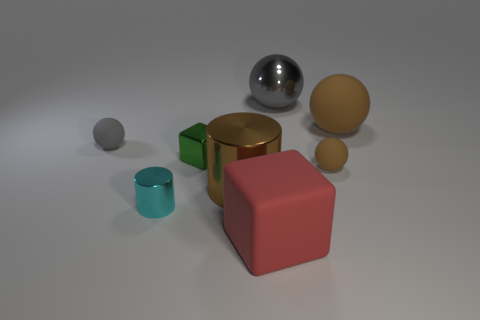There is a brown thing that is to the right of the brown matte thing that is left of the big brown object that is behind the large cylinder; what is its material?
Your response must be concise. Rubber. Does the shiny thing that is right of the red matte object have the same size as the rubber block?
Provide a succinct answer. Yes. Are there more large objects than tiny cyan cylinders?
Offer a very short reply. Yes. How many large objects are gray metal balls or red things?
Offer a very short reply. 2. What number of other things are the same color as the big metal cylinder?
Make the answer very short. 2. How many big things are the same material as the large brown cylinder?
Your answer should be compact. 1. Is the color of the rubber ball left of the large red block the same as the metallic cube?
Ensure brevity in your answer.  No. How many gray things are either small cylinders or metallic balls?
Your answer should be compact. 1. Is the material of the cube that is right of the brown cylinder the same as the tiny cyan cylinder?
Give a very brief answer. No. What number of objects are tiny spheres or big gray metal spheres on the left side of the tiny brown rubber object?
Offer a terse response. 3. 